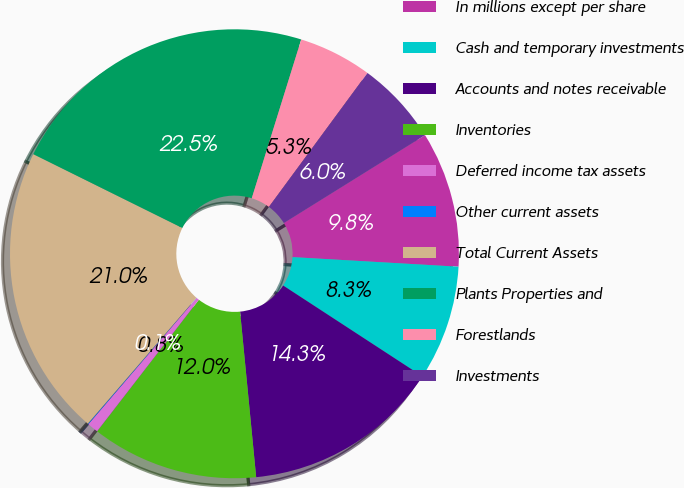<chart> <loc_0><loc_0><loc_500><loc_500><pie_chart><fcel>In millions except per share<fcel>Cash and temporary investments<fcel>Accounts and notes receivable<fcel>Inventories<fcel>Deferred income tax assets<fcel>Other current assets<fcel>Total Current Assets<fcel>Plants Properties and<fcel>Forestlands<fcel>Investments<nl><fcel>9.78%<fcel>8.28%<fcel>14.26%<fcel>12.02%<fcel>0.8%<fcel>0.05%<fcel>20.99%<fcel>22.49%<fcel>5.29%<fcel>6.04%<nl></chart> 